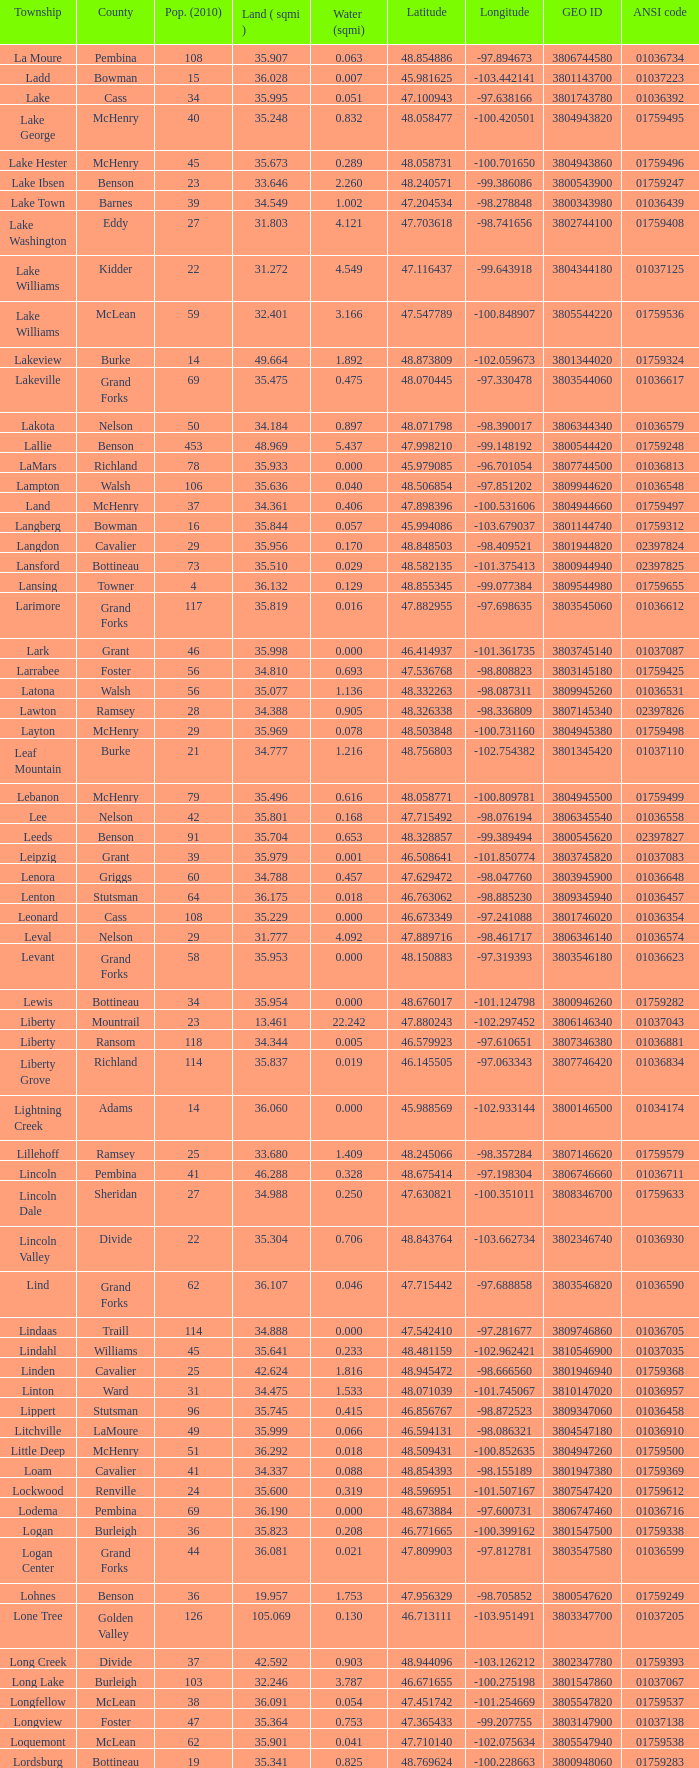For a 2010 population of 24 and water quantity above 0.319, what is the value of the latitude? None. 